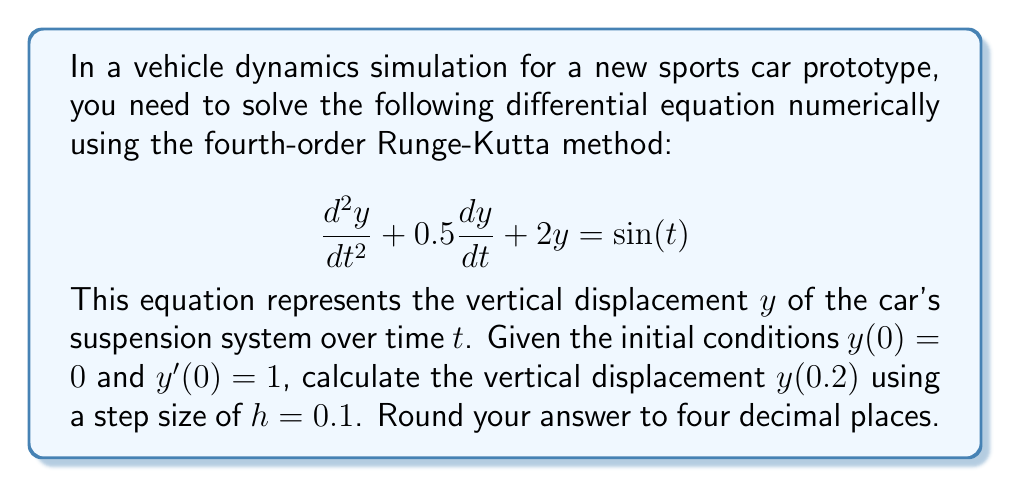What is the answer to this math problem? To solve this second-order differential equation using the fourth-order Runge-Kutta method, we need to convert it into a system of first-order equations:

Let $y_1 = y$ and $y_2 = \frac{dy}{dt}$. Then:

$$\frac{dy_1}{dt} = y_2$$
$$\frac{dy_2}{dt} = -0.5y_2 - 2y_1 + \sin(t)$$

Now we can apply the fourth-order Runge-Kutta method:

$$k_{1,i} = hf_i(t_n, y_{1,n}, y_{2,n})$$
$$k_{2,i} = hf_i(t_n + \frac{h}{2}, y_{1,n} + \frac{k_{1,1}}{2}, y_{2,n} + \frac{k_{1,2}}{2})$$
$$k_{3,i} = hf_i(t_n + \frac{h}{2}, y_{1,n} + \frac{k_{2,1}}{2}, y_{2,n} + \frac{k_{2,2}}{2})$$
$$k_{4,i} = hf_i(t_n + h, y_{1,n} + k_{3,1}, y_{2,n} + k_{3,2})$$

$$y_{i,n+1} = y_{i,n} + \frac{1}{6}(k_{1,i} + 2k_{2,i} + 2k_{3,i} + k_{4,i})$$

Where $i = 1, 2$ for each equation, and $n$ is the step number.

Given: $h = 0.1$, $y_1(0) = 0$, $y_2(0) = 1$

Step 1: Calculate values for $t = 0.1$
$k_{1,1} = 0.1 \cdot 1 = 0.1$
$k_{1,2} = 0.1 \cdot (-0.5 \cdot 1 - 2 \cdot 0 + \sin(0)) = -0.05$

$k_{2,1} = 0.1 \cdot (1 + \frac{-0.05}{2}) = 0.09875$
$k_{2,2} = 0.1 \cdot (-0.5 \cdot (1 + \frac{-0.05}{2}) - 2 \cdot (0 + \frac{0.1}{2}) + \sin(0.05)) = -0.0549$

$k_{3,1} = 0.1 \cdot (1 + \frac{-0.0549}{2}) = 0.09726$
$k_{3,2} = 0.1 \cdot (-0.5 \cdot (1 + \frac{-0.0549}{2}) - 2 \cdot (0 + \frac{0.09875}{2}) + \sin(0.05)) = -0.0597$

$k_{4,1} = 0.1 \cdot (1 - 0.0597) = 0.09403$
$k_{4,2} = 0.1 \cdot (-0.5 \cdot (1 - 0.0597) - 2 \cdot (0 + 0.09726) + \sin(0.1)) = -0.0644$

$y_1(0.1) = 0 + \frac{1}{6}(0.1 + 2 \cdot 0.09875 + 2 \cdot 0.09726 + 0.09403) = 0.0980$
$y_2(0.1) = 1 + \frac{1}{6}(-0.05 + 2 \cdot (-0.0549) + 2 \cdot (-0.0597) + (-0.0644)) = 0.9446$

Step 2: Calculate values for $t = 0.2$
Using the same process as above, but with initial values $y_1(0.1) = 0.0980$ and $y_2(0.1) = 0.9446$, we get:

$y_1(0.2) = 0.1921$
$y_2(0.2) = 0.8799$
Answer: 0.1921 